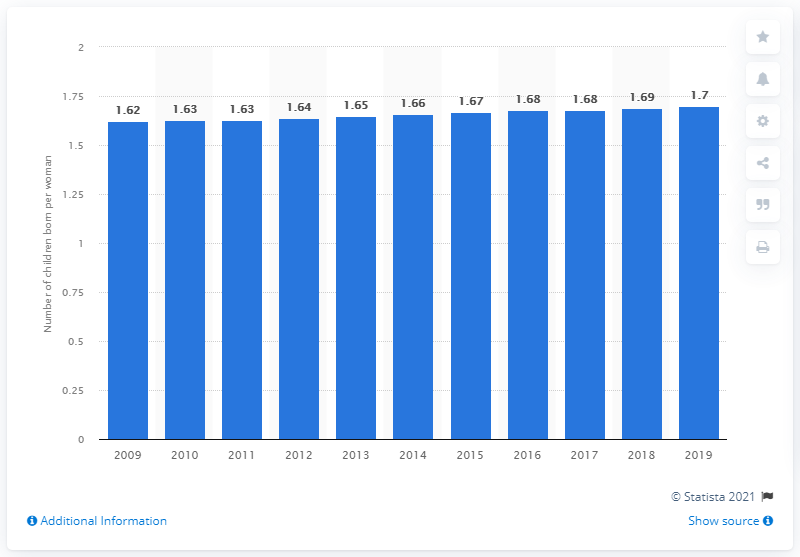Highlight a few significant elements in this photo. In 2019, the fertility rate in China was 1.7. 